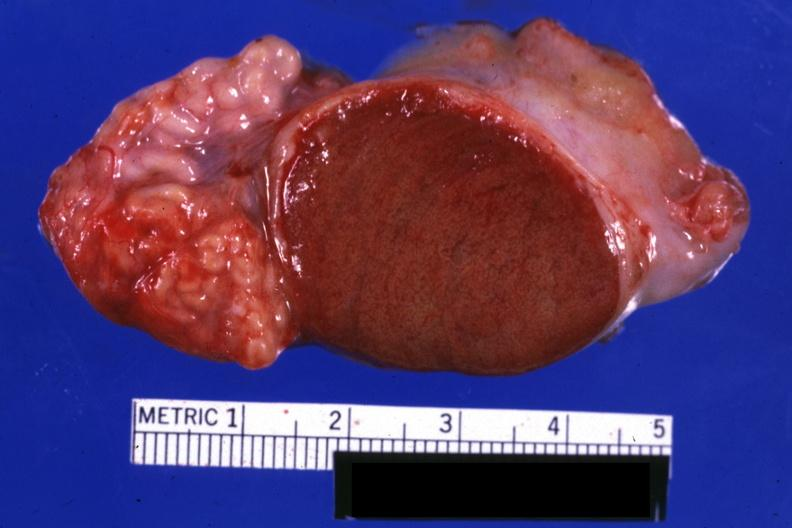s normal present?
Answer the question using a single word or phrase. Yes 